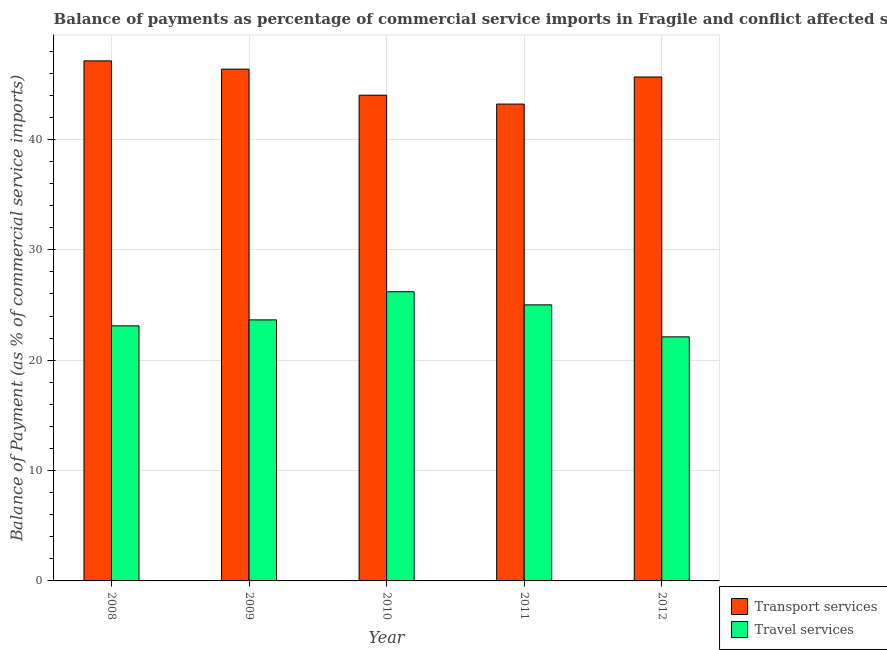How many different coloured bars are there?
Provide a short and direct response. 2. How many groups of bars are there?
Provide a short and direct response. 5. Are the number of bars on each tick of the X-axis equal?
Offer a very short reply. Yes. What is the label of the 1st group of bars from the left?
Offer a terse response. 2008. In how many cases, is the number of bars for a given year not equal to the number of legend labels?
Make the answer very short. 0. What is the balance of payments of travel services in 2008?
Provide a short and direct response. 23.11. Across all years, what is the maximum balance of payments of travel services?
Make the answer very short. 26.2. Across all years, what is the minimum balance of payments of transport services?
Provide a short and direct response. 43.2. In which year was the balance of payments of transport services maximum?
Make the answer very short. 2008. In which year was the balance of payments of transport services minimum?
Ensure brevity in your answer.  2011. What is the total balance of payments of travel services in the graph?
Your response must be concise. 120.07. What is the difference between the balance of payments of travel services in 2009 and that in 2011?
Your answer should be compact. -1.36. What is the difference between the balance of payments of travel services in 2012 and the balance of payments of transport services in 2008?
Provide a succinct answer. -0.99. What is the average balance of payments of transport services per year?
Keep it short and to the point. 45.27. What is the ratio of the balance of payments of travel services in 2010 to that in 2011?
Offer a very short reply. 1.05. Is the balance of payments of travel services in 2008 less than that in 2011?
Your answer should be very brief. Yes. What is the difference between the highest and the second highest balance of payments of travel services?
Your answer should be compact. 1.19. What is the difference between the highest and the lowest balance of payments of travel services?
Provide a succinct answer. 4.09. In how many years, is the balance of payments of transport services greater than the average balance of payments of transport services taken over all years?
Give a very brief answer. 3. What does the 1st bar from the left in 2011 represents?
Provide a short and direct response. Transport services. What does the 2nd bar from the right in 2009 represents?
Make the answer very short. Transport services. Are all the bars in the graph horizontal?
Provide a succinct answer. No. How many years are there in the graph?
Provide a succinct answer. 5. Where does the legend appear in the graph?
Your answer should be very brief. Bottom right. How are the legend labels stacked?
Provide a succinct answer. Vertical. What is the title of the graph?
Offer a very short reply. Balance of payments as percentage of commercial service imports in Fragile and conflict affected situations. What is the label or title of the X-axis?
Your response must be concise. Year. What is the label or title of the Y-axis?
Your answer should be very brief. Balance of Payment (as % of commercial service imports). What is the Balance of Payment (as % of commercial service imports) in Transport services in 2008?
Your response must be concise. 47.11. What is the Balance of Payment (as % of commercial service imports) of Travel services in 2008?
Provide a succinct answer. 23.11. What is the Balance of Payment (as % of commercial service imports) in Transport services in 2009?
Make the answer very short. 46.36. What is the Balance of Payment (as % of commercial service imports) in Travel services in 2009?
Make the answer very short. 23.65. What is the Balance of Payment (as % of commercial service imports) of Transport services in 2010?
Offer a very short reply. 44. What is the Balance of Payment (as % of commercial service imports) of Travel services in 2010?
Ensure brevity in your answer.  26.2. What is the Balance of Payment (as % of commercial service imports) of Transport services in 2011?
Provide a short and direct response. 43.2. What is the Balance of Payment (as % of commercial service imports) in Travel services in 2011?
Give a very brief answer. 25.01. What is the Balance of Payment (as % of commercial service imports) of Transport services in 2012?
Provide a succinct answer. 45.66. What is the Balance of Payment (as % of commercial service imports) in Travel services in 2012?
Offer a terse response. 22.11. Across all years, what is the maximum Balance of Payment (as % of commercial service imports) of Transport services?
Make the answer very short. 47.11. Across all years, what is the maximum Balance of Payment (as % of commercial service imports) of Travel services?
Your answer should be compact. 26.2. Across all years, what is the minimum Balance of Payment (as % of commercial service imports) of Transport services?
Your answer should be very brief. 43.2. Across all years, what is the minimum Balance of Payment (as % of commercial service imports) in Travel services?
Keep it short and to the point. 22.11. What is the total Balance of Payment (as % of commercial service imports) in Transport services in the graph?
Give a very brief answer. 226.34. What is the total Balance of Payment (as % of commercial service imports) in Travel services in the graph?
Ensure brevity in your answer.  120.07. What is the difference between the Balance of Payment (as % of commercial service imports) of Transport services in 2008 and that in 2009?
Your response must be concise. 0.75. What is the difference between the Balance of Payment (as % of commercial service imports) in Travel services in 2008 and that in 2009?
Ensure brevity in your answer.  -0.54. What is the difference between the Balance of Payment (as % of commercial service imports) in Transport services in 2008 and that in 2010?
Offer a terse response. 3.11. What is the difference between the Balance of Payment (as % of commercial service imports) of Travel services in 2008 and that in 2010?
Provide a succinct answer. -3.09. What is the difference between the Balance of Payment (as % of commercial service imports) in Transport services in 2008 and that in 2011?
Offer a terse response. 3.91. What is the difference between the Balance of Payment (as % of commercial service imports) of Travel services in 2008 and that in 2011?
Keep it short and to the point. -1.9. What is the difference between the Balance of Payment (as % of commercial service imports) in Transport services in 2008 and that in 2012?
Make the answer very short. 1.46. What is the difference between the Balance of Payment (as % of commercial service imports) of Travel services in 2008 and that in 2012?
Your answer should be very brief. 0.99. What is the difference between the Balance of Payment (as % of commercial service imports) of Transport services in 2009 and that in 2010?
Provide a succinct answer. 2.36. What is the difference between the Balance of Payment (as % of commercial service imports) of Travel services in 2009 and that in 2010?
Your answer should be compact. -2.55. What is the difference between the Balance of Payment (as % of commercial service imports) in Transport services in 2009 and that in 2011?
Your answer should be compact. 3.16. What is the difference between the Balance of Payment (as % of commercial service imports) of Travel services in 2009 and that in 2011?
Give a very brief answer. -1.36. What is the difference between the Balance of Payment (as % of commercial service imports) of Transport services in 2009 and that in 2012?
Ensure brevity in your answer.  0.71. What is the difference between the Balance of Payment (as % of commercial service imports) of Travel services in 2009 and that in 2012?
Your response must be concise. 1.54. What is the difference between the Balance of Payment (as % of commercial service imports) in Transport services in 2010 and that in 2011?
Offer a very short reply. 0.8. What is the difference between the Balance of Payment (as % of commercial service imports) of Travel services in 2010 and that in 2011?
Provide a short and direct response. 1.19. What is the difference between the Balance of Payment (as % of commercial service imports) of Transport services in 2010 and that in 2012?
Ensure brevity in your answer.  -1.65. What is the difference between the Balance of Payment (as % of commercial service imports) in Travel services in 2010 and that in 2012?
Offer a terse response. 4.09. What is the difference between the Balance of Payment (as % of commercial service imports) of Transport services in 2011 and that in 2012?
Your response must be concise. -2.45. What is the difference between the Balance of Payment (as % of commercial service imports) of Travel services in 2011 and that in 2012?
Give a very brief answer. 2.9. What is the difference between the Balance of Payment (as % of commercial service imports) of Transport services in 2008 and the Balance of Payment (as % of commercial service imports) of Travel services in 2009?
Offer a very short reply. 23.47. What is the difference between the Balance of Payment (as % of commercial service imports) of Transport services in 2008 and the Balance of Payment (as % of commercial service imports) of Travel services in 2010?
Your answer should be compact. 20.92. What is the difference between the Balance of Payment (as % of commercial service imports) of Transport services in 2008 and the Balance of Payment (as % of commercial service imports) of Travel services in 2011?
Provide a short and direct response. 22.11. What is the difference between the Balance of Payment (as % of commercial service imports) of Transport services in 2008 and the Balance of Payment (as % of commercial service imports) of Travel services in 2012?
Offer a very short reply. 25. What is the difference between the Balance of Payment (as % of commercial service imports) in Transport services in 2009 and the Balance of Payment (as % of commercial service imports) in Travel services in 2010?
Provide a short and direct response. 20.17. What is the difference between the Balance of Payment (as % of commercial service imports) of Transport services in 2009 and the Balance of Payment (as % of commercial service imports) of Travel services in 2011?
Ensure brevity in your answer.  21.36. What is the difference between the Balance of Payment (as % of commercial service imports) of Transport services in 2009 and the Balance of Payment (as % of commercial service imports) of Travel services in 2012?
Ensure brevity in your answer.  24.25. What is the difference between the Balance of Payment (as % of commercial service imports) in Transport services in 2010 and the Balance of Payment (as % of commercial service imports) in Travel services in 2011?
Keep it short and to the point. 19. What is the difference between the Balance of Payment (as % of commercial service imports) in Transport services in 2010 and the Balance of Payment (as % of commercial service imports) in Travel services in 2012?
Offer a very short reply. 21.89. What is the difference between the Balance of Payment (as % of commercial service imports) of Transport services in 2011 and the Balance of Payment (as % of commercial service imports) of Travel services in 2012?
Give a very brief answer. 21.09. What is the average Balance of Payment (as % of commercial service imports) in Transport services per year?
Make the answer very short. 45.27. What is the average Balance of Payment (as % of commercial service imports) in Travel services per year?
Offer a very short reply. 24.01. In the year 2008, what is the difference between the Balance of Payment (as % of commercial service imports) in Transport services and Balance of Payment (as % of commercial service imports) in Travel services?
Keep it short and to the point. 24.01. In the year 2009, what is the difference between the Balance of Payment (as % of commercial service imports) in Transport services and Balance of Payment (as % of commercial service imports) in Travel services?
Provide a short and direct response. 22.72. In the year 2010, what is the difference between the Balance of Payment (as % of commercial service imports) in Transport services and Balance of Payment (as % of commercial service imports) in Travel services?
Make the answer very short. 17.81. In the year 2011, what is the difference between the Balance of Payment (as % of commercial service imports) in Transport services and Balance of Payment (as % of commercial service imports) in Travel services?
Offer a terse response. 18.19. In the year 2012, what is the difference between the Balance of Payment (as % of commercial service imports) of Transport services and Balance of Payment (as % of commercial service imports) of Travel services?
Keep it short and to the point. 23.54. What is the ratio of the Balance of Payment (as % of commercial service imports) of Transport services in 2008 to that in 2009?
Provide a succinct answer. 1.02. What is the ratio of the Balance of Payment (as % of commercial service imports) in Transport services in 2008 to that in 2010?
Give a very brief answer. 1.07. What is the ratio of the Balance of Payment (as % of commercial service imports) in Travel services in 2008 to that in 2010?
Offer a terse response. 0.88. What is the ratio of the Balance of Payment (as % of commercial service imports) of Transport services in 2008 to that in 2011?
Offer a terse response. 1.09. What is the ratio of the Balance of Payment (as % of commercial service imports) in Travel services in 2008 to that in 2011?
Your answer should be compact. 0.92. What is the ratio of the Balance of Payment (as % of commercial service imports) in Transport services in 2008 to that in 2012?
Offer a very short reply. 1.03. What is the ratio of the Balance of Payment (as % of commercial service imports) of Travel services in 2008 to that in 2012?
Provide a short and direct response. 1.04. What is the ratio of the Balance of Payment (as % of commercial service imports) in Transport services in 2009 to that in 2010?
Keep it short and to the point. 1.05. What is the ratio of the Balance of Payment (as % of commercial service imports) of Travel services in 2009 to that in 2010?
Make the answer very short. 0.9. What is the ratio of the Balance of Payment (as % of commercial service imports) in Transport services in 2009 to that in 2011?
Provide a short and direct response. 1.07. What is the ratio of the Balance of Payment (as % of commercial service imports) of Travel services in 2009 to that in 2011?
Offer a very short reply. 0.95. What is the ratio of the Balance of Payment (as % of commercial service imports) of Transport services in 2009 to that in 2012?
Make the answer very short. 1.02. What is the ratio of the Balance of Payment (as % of commercial service imports) of Travel services in 2009 to that in 2012?
Give a very brief answer. 1.07. What is the ratio of the Balance of Payment (as % of commercial service imports) in Transport services in 2010 to that in 2011?
Offer a terse response. 1.02. What is the ratio of the Balance of Payment (as % of commercial service imports) in Travel services in 2010 to that in 2011?
Ensure brevity in your answer.  1.05. What is the ratio of the Balance of Payment (as % of commercial service imports) of Transport services in 2010 to that in 2012?
Keep it short and to the point. 0.96. What is the ratio of the Balance of Payment (as % of commercial service imports) in Travel services in 2010 to that in 2012?
Keep it short and to the point. 1.18. What is the ratio of the Balance of Payment (as % of commercial service imports) in Transport services in 2011 to that in 2012?
Your answer should be compact. 0.95. What is the ratio of the Balance of Payment (as % of commercial service imports) of Travel services in 2011 to that in 2012?
Keep it short and to the point. 1.13. What is the difference between the highest and the second highest Balance of Payment (as % of commercial service imports) in Transport services?
Provide a succinct answer. 0.75. What is the difference between the highest and the second highest Balance of Payment (as % of commercial service imports) in Travel services?
Provide a succinct answer. 1.19. What is the difference between the highest and the lowest Balance of Payment (as % of commercial service imports) of Transport services?
Your answer should be very brief. 3.91. What is the difference between the highest and the lowest Balance of Payment (as % of commercial service imports) of Travel services?
Your response must be concise. 4.09. 